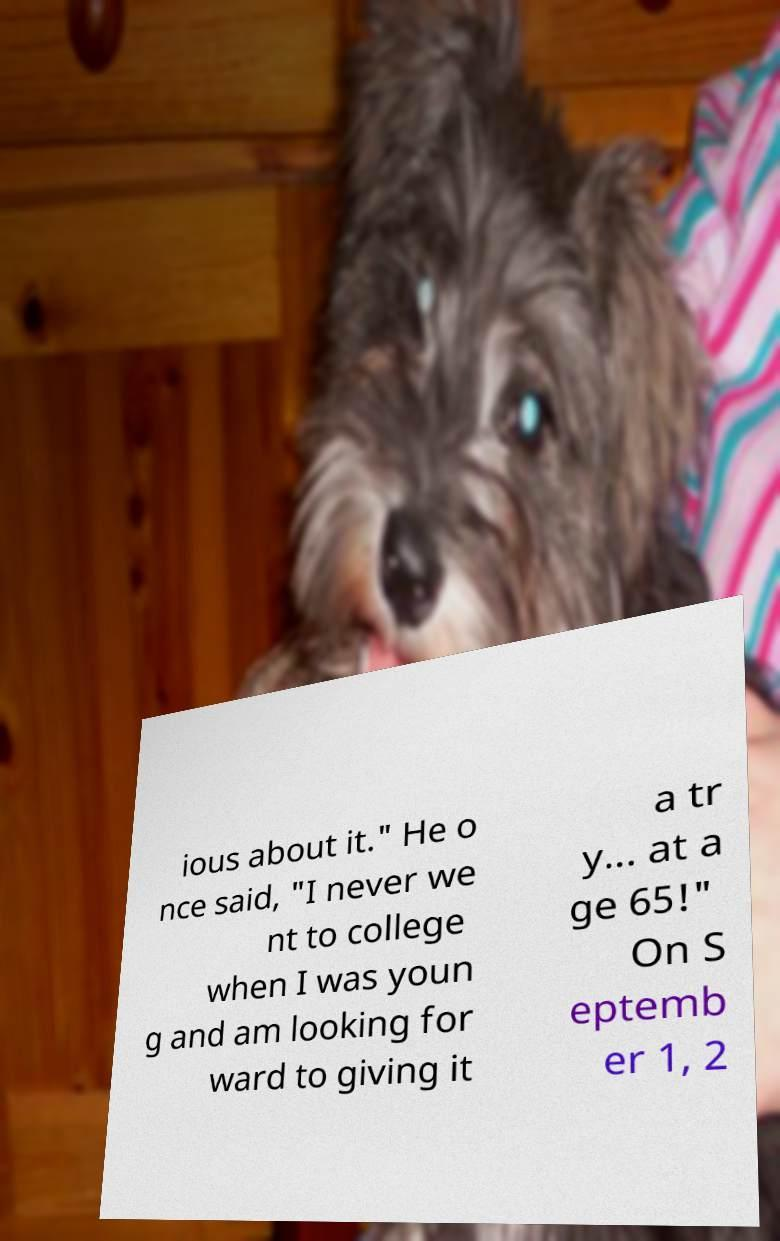I need the written content from this picture converted into text. Can you do that? ious about it." He o nce said, "I never we nt to college when I was youn g and am looking for ward to giving it a tr y... at a ge 65!" On S eptemb er 1, 2 